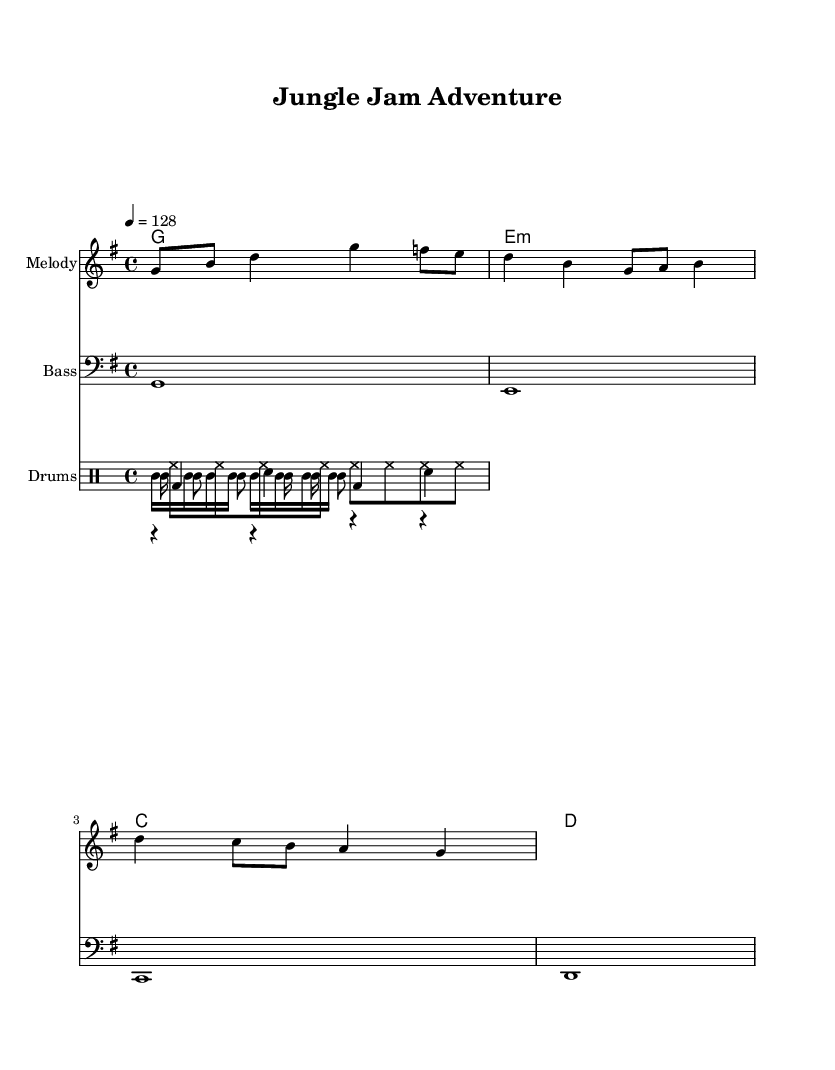What is the key signature of this music? The key signature shows one sharp, indicating that the music is in G major, which is the key used in this piece.
Answer: G major What is the time signature of this piece? The time signature is 4/4, which means there are four beats in a measure and the quarter note gets one beat, as indicated at the beginning of the score.
Answer: 4/4 What is the tempo marking for this composition? The tempo marking is indicated as "4 = 128," meaning there are 128 beats per minute, which suggests a moderately fast pace suitable for dance music.
Answer: 128 Which instruments are included in the drum part? The drum part comprises kick, snare, hi-hat, conga, and shaker, as listed within their respective drum voices in the score layout.
Answer: Kick, snare, hi-hat, conga, shaker How many measures does the melody contain before repeating? The melody contains three measures as can be seen in the notation, consisting of different notes and rhythms before introducing variations.
Answer: 3 measures What type of harmony is being used in the score? The harmony section uses triads, specifically a mix of G major, E minor, C major, and D major chords, indicating a rich harmonic structure common in dance music.
Answer: Triads What overall theme does this dance music celebrate? The title "Jungle Jam Adventure" and its lively style suggest that the theme celebrates outdoor activities and nature exploration, aligning with the tropical and adventurous vibe of the music.
Answer: Outdoor activities and nature exploration 